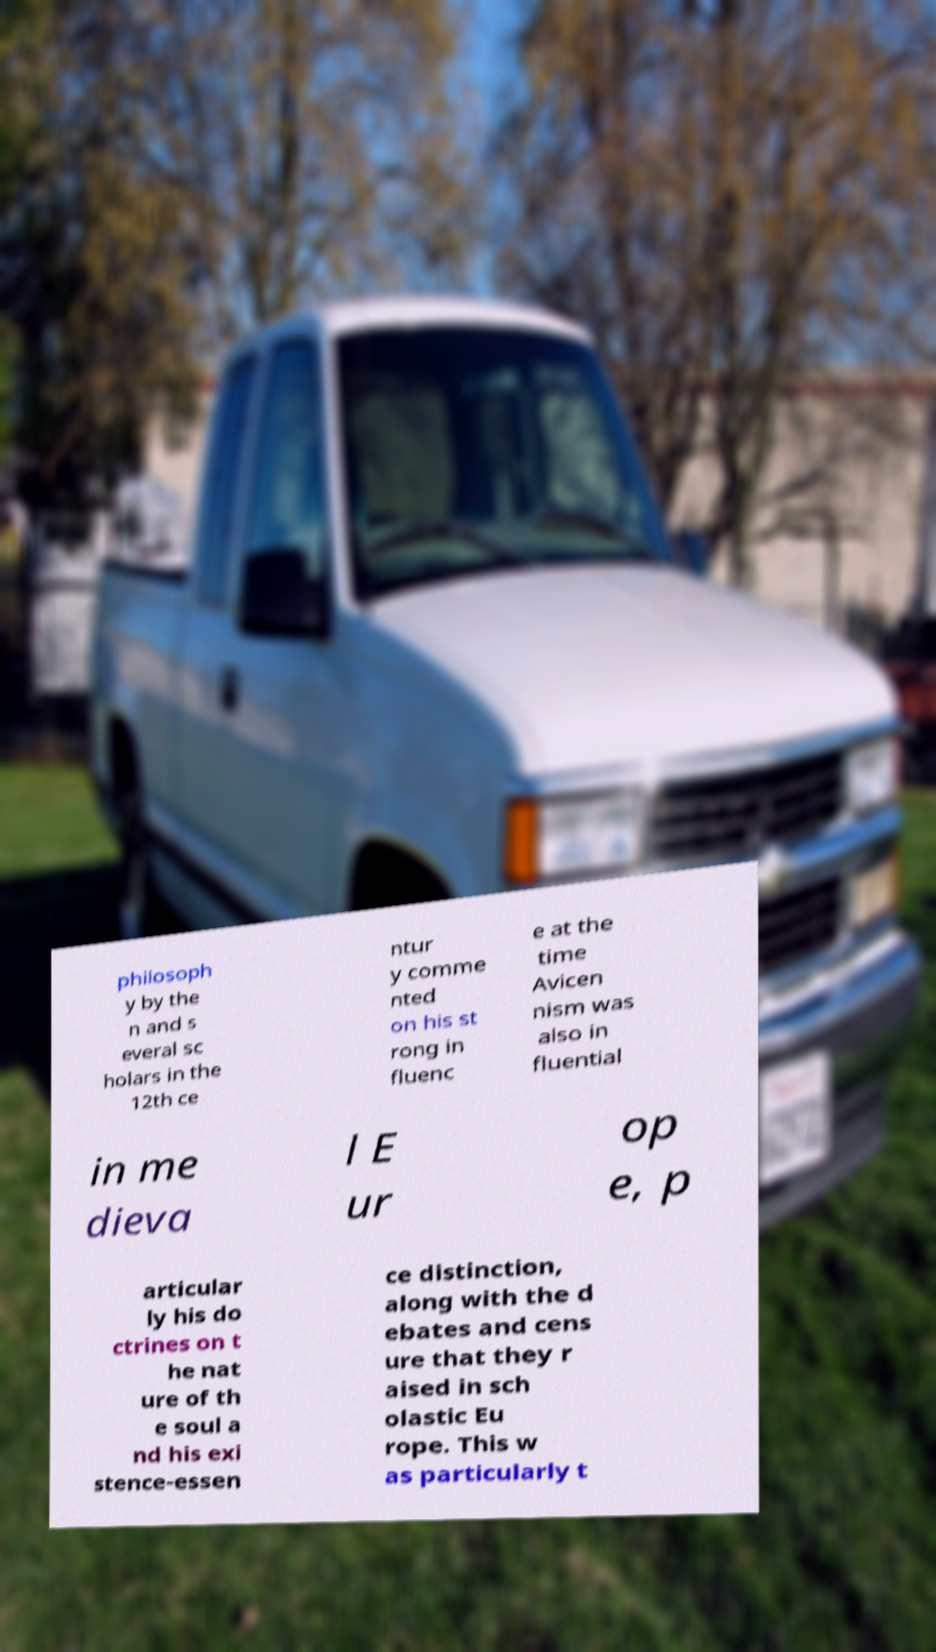Please read and relay the text visible in this image. What does it say? philosoph y by the n and s everal sc holars in the 12th ce ntur y comme nted on his st rong in fluenc e at the time Avicen nism was also in fluential in me dieva l E ur op e, p articular ly his do ctrines on t he nat ure of th e soul a nd his exi stence-essen ce distinction, along with the d ebates and cens ure that they r aised in sch olastic Eu rope. This w as particularly t 